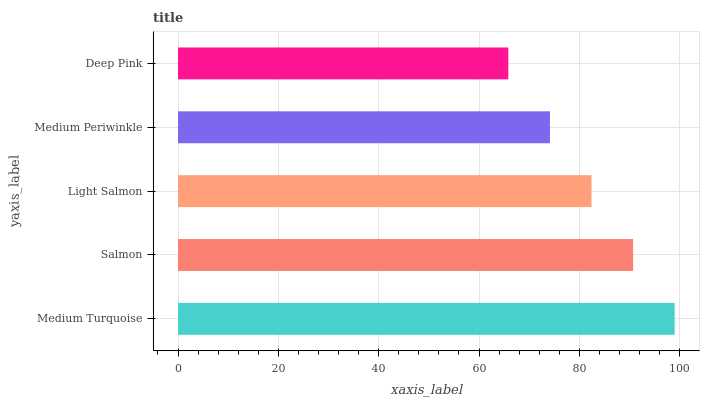Is Deep Pink the minimum?
Answer yes or no. Yes. Is Medium Turquoise the maximum?
Answer yes or no. Yes. Is Salmon the minimum?
Answer yes or no. No. Is Salmon the maximum?
Answer yes or no. No. Is Medium Turquoise greater than Salmon?
Answer yes or no. Yes. Is Salmon less than Medium Turquoise?
Answer yes or no. Yes. Is Salmon greater than Medium Turquoise?
Answer yes or no. No. Is Medium Turquoise less than Salmon?
Answer yes or no. No. Is Light Salmon the high median?
Answer yes or no. Yes. Is Light Salmon the low median?
Answer yes or no. Yes. Is Salmon the high median?
Answer yes or no. No. Is Salmon the low median?
Answer yes or no. No. 